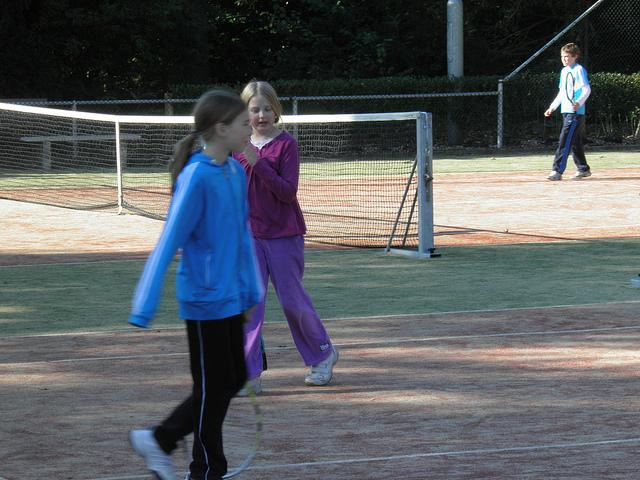What hair style does the girl in blue have? Please explain your reasoning. pony tail. Her hair has one scrunchie near at the back of her head while the rest below the scrunchie are freeflowing. 